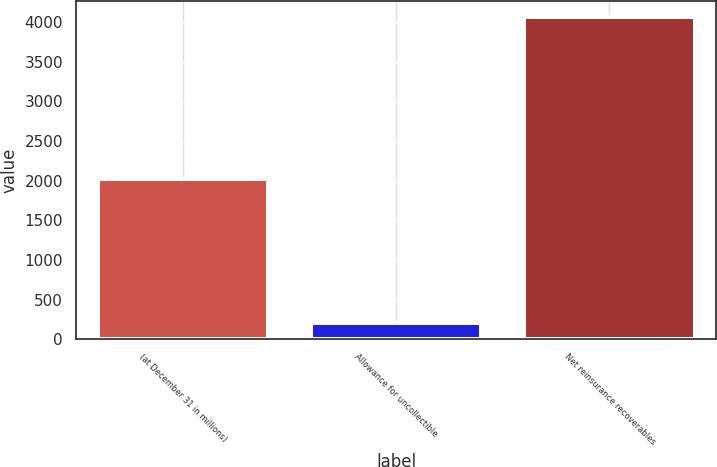Convert chart to OTSL. <chart><loc_0><loc_0><loc_500><loc_500><bar_chart><fcel>(at December 31 in millions)<fcel>Allowance for uncollectible<fcel>Net reinsurance recoverables<nl><fcel>2014<fcel>203<fcel>4067<nl></chart> 